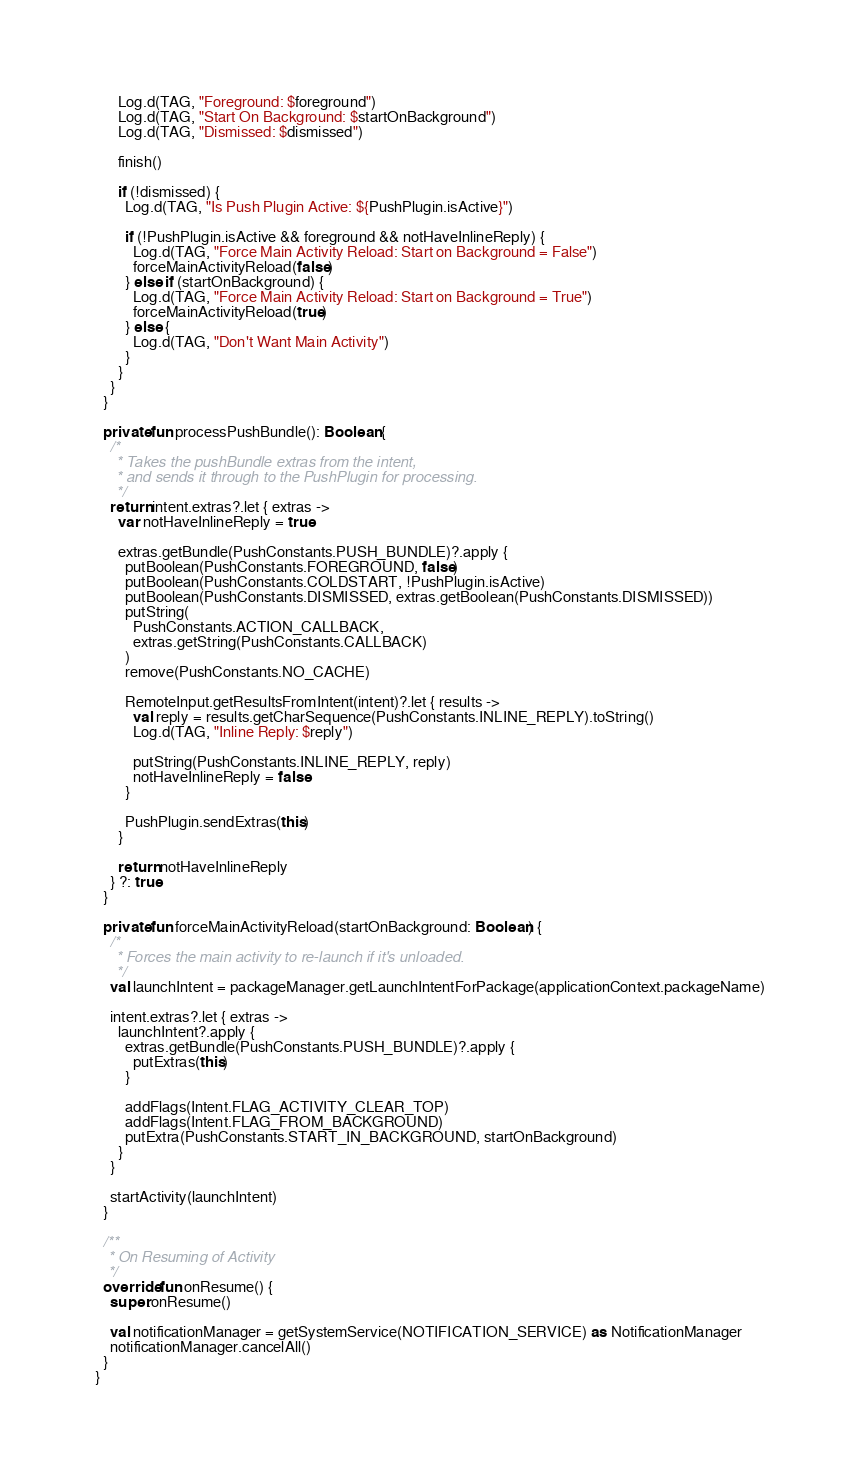Convert code to text. <code><loc_0><loc_0><loc_500><loc_500><_Kotlin_>      Log.d(TAG, "Foreground: $foreground")
      Log.d(TAG, "Start On Background: $startOnBackground")
      Log.d(TAG, "Dismissed: $dismissed")

      finish()

      if (!dismissed) {
        Log.d(TAG, "Is Push Plugin Active: ${PushPlugin.isActive}")

        if (!PushPlugin.isActive && foreground && notHaveInlineReply) {
          Log.d(TAG, "Force Main Activity Reload: Start on Background = False")
          forceMainActivityReload(false)
        } else if (startOnBackground) {
          Log.d(TAG, "Force Main Activity Reload: Start on Background = True")
          forceMainActivityReload(true)
        } else {
          Log.d(TAG, "Don't Want Main Activity")
        }
      }
    }
  }

  private fun processPushBundle(): Boolean {
    /*
     * Takes the pushBundle extras from the intent,
     * and sends it through to the PushPlugin for processing.
     */
    return intent.extras?.let { extras ->
      var notHaveInlineReply = true

      extras.getBundle(PushConstants.PUSH_BUNDLE)?.apply {
        putBoolean(PushConstants.FOREGROUND, false)
        putBoolean(PushConstants.COLDSTART, !PushPlugin.isActive)
        putBoolean(PushConstants.DISMISSED, extras.getBoolean(PushConstants.DISMISSED))
        putString(
          PushConstants.ACTION_CALLBACK,
          extras.getString(PushConstants.CALLBACK)
        )
        remove(PushConstants.NO_CACHE)

        RemoteInput.getResultsFromIntent(intent)?.let { results ->
          val reply = results.getCharSequence(PushConstants.INLINE_REPLY).toString()
          Log.d(TAG, "Inline Reply: $reply")

          putString(PushConstants.INLINE_REPLY, reply)
          notHaveInlineReply = false
        }

        PushPlugin.sendExtras(this)
      }

      return notHaveInlineReply
    } ?: true
  }

  private fun forceMainActivityReload(startOnBackground: Boolean) {
    /*
     * Forces the main activity to re-launch if it's unloaded.
     */
    val launchIntent = packageManager.getLaunchIntentForPackage(applicationContext.packageName)

    intent.extras?.let { extras ->
      launchIntent?.apply {
        extras.getBundle(PushConstants.PUSH_BUNDLE)?.apply {
          putExtras(this)
        }

        addFlags(Intent.FLAG_ACTIVITY_CLEAR_TOP)
        addFlags(Intent.FLAG_FROM_BACKGROUND)
        putExtra(PushConstants.START_IN_BACKGROUND, startOnBackground)
      }
    }

    startActivity(launchIntent)
  }

  /**
   * On Resuming of Activity
   */
  override fun onResume() {
    super.onResume()

    val notificationManager = getSystemService(NOTIFICATION_SERVICE) as NotificationManager
    notificationManager.cancelAll()
  }
}
</code> 